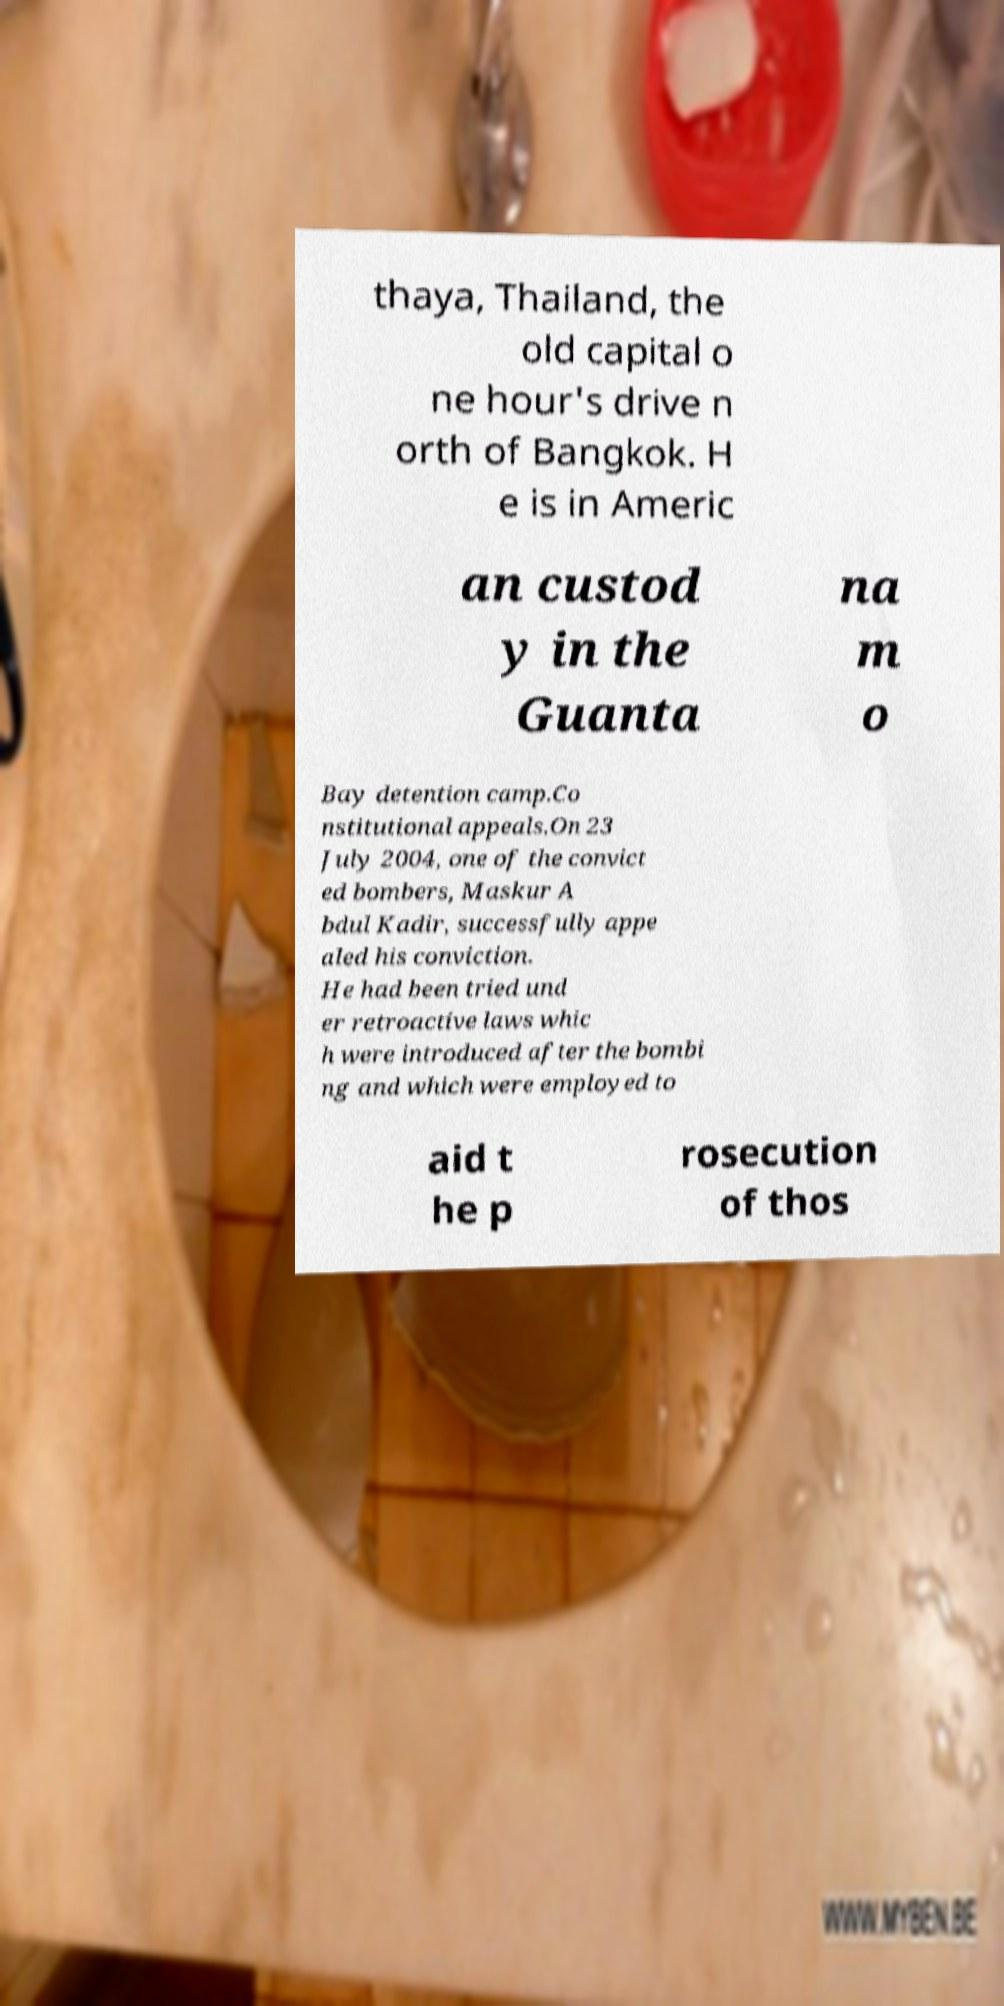Can you read and provide the text displayed in the image?This photo seems to have some interesting text. Can you extract and type it out for me? thaya, Thailand, the old capital o ne hour's drive n orth of Bangkok. H e is in Americ an custod y in the Guanta na m o Bay detention camp.Co nstitutional appeals.On 23 July 2004, one of the convict ed bombers, Maskur A bdul Kadir, successfully appe aled his conviction. He had been tried und er retroactive laws whic h were introduced after the bombi ng and which were employed to aid t he p rosecution of thos 